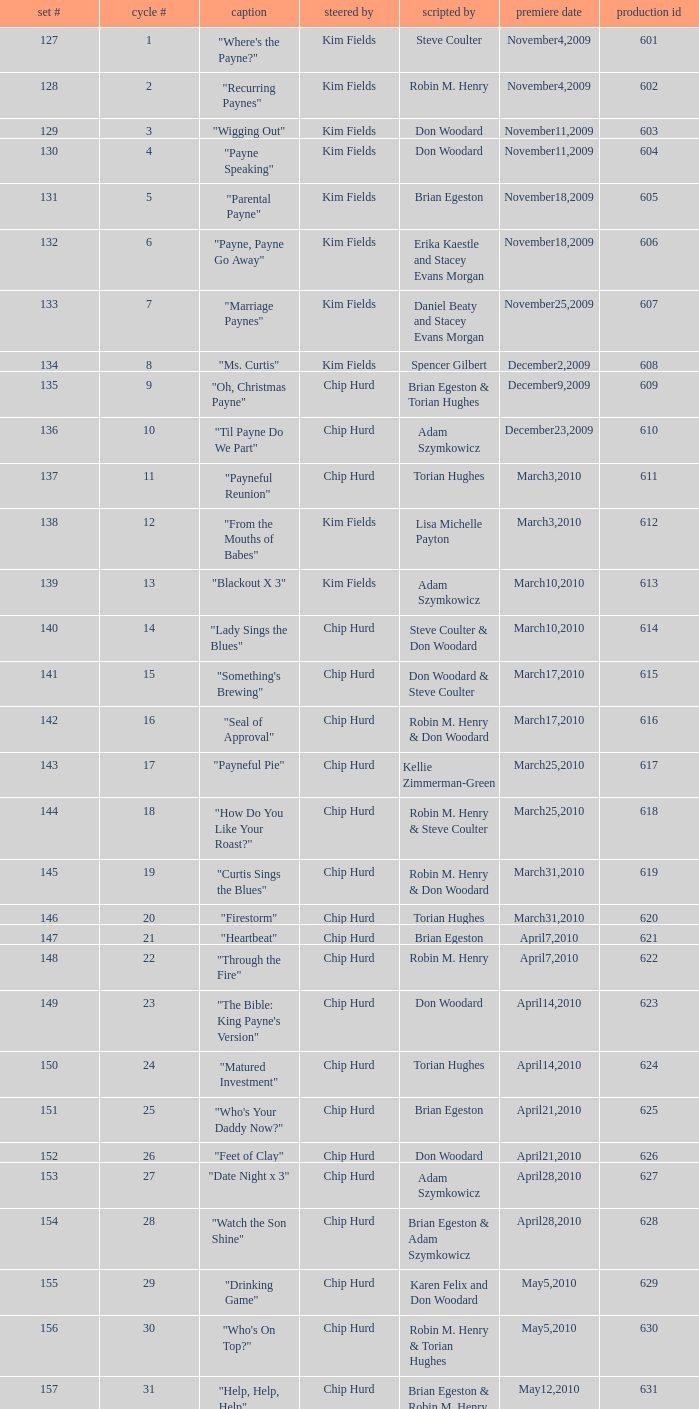What is the original air date of the episode written by Karen Felix and Don Woodard? May5,2010. Write the full table. {'header': ['set #', 'cycle #', 'caption', 'steered by', 'scripted by', 'premiere date', 'production id'], 'rows': [['127', '1', '"Where\'s the Payne?"', 'Kim Fields', 'Steve Coulter', 'November4,2009', '601'], ['128', '2', '"Recurring Paynes"', 'Kim Fields', 'Robin M. Henry', 'November4,2009', '602'], ['129', '3', '"Wigging Out"', 'Kim Fields', 'Don Woodard', 'November11,2009', '603'], ['130', '4', '"Payne Speaking"', 'Kim Fields', 'Don Woodard', 'November11,2009', '604'], ['131', '5', '"Parental Payne"', 'Kim Fields', 'Brian Egeston', 'November18,2009', '605'], ['132', '6', '"Payne, Payne Go Away"', 'Kim Fields', 'Erika Kaestle and Stacey Evans Morgan', 'November18,2009', '606'], ['133', '7', '"Marriage Paynes"', 'Kim Fields', 'Daniel Beaty and Stacey Evans Morgan', 'November25,2009', '607'], ['134', '8', '"Ms. Curtis"', 'Kim Fields', 'Spencer Gilbert', 'December2,2009', '608'], ['135', '9', '"Oh, Christmas Payne"', 'Chip Hurd', 'Brian Egeston & Torian Hughes', 'December9,2009', '609'], ['136', '10', '"Til Payne Do We Part"', 'Chip Hurd', 'Adam Szymkowicz', 'December23,2009', '610'], ['137', '11', '"Payneful Reunion"', 'Chip Hurd', 'Torian Hughes', 'March3,2010', '611'], ['138', '12', '"From the Mouths of Babes"', 'Kim Fields', 'Lisa Michelle Payton', 'March3,2010', '612'], ['139', '13', '"Blackout X 3"', 'Kim Fields', 'Adam Szymkowicz', 'March10,2010', '613'], ['140', '14', '"Lady Sings the Blues"', 'Chip Hurd', 'Steve Coulter & Don Woodard', 'March10,2010', '614'], ['141', '15', '"Something\'s Brewing"', 'Chip Hurd', 'Don Woodard & Steve Coulter', 'March17,2010', '615'], ['142', '16', '"Seal of Approval"', 'Chip Hurd', 'Robin M. Henry & Don Woodard', 'March17,2010', '616'], ['143', '17', '"Payneful Pie"', 'Chip Hurd', 'Kellie Zimmerman-Green', 'March25,2010', '617'], ['144', '18', '"How Do You Like Your Roast?"', 'Chip Hurd', 'Robin M. Henry & Steve Coulter', 'March25,2010', '618'], ['145', '19', '"Curtis Sings the Blues"', 'Chip Hurd', 'Robin M. Henry & Don Woodard', 'March31,2010', '619'], ['146', '20', '"Firestorm"', 'Chip Hurd', 'Torian Hughes', 'March31,2010', '620'], ['147', '21', '"Heartbeat"', 'Chip Hurd', 'Brian Egeston', 'April7,2010', '621'], ['148', '22', '"Through the Fire"', 'Chip Hurd', 'Robin M. Henry', 'April7,2010', '622'], ['149', '23', '"The Bible: King Payne\'s Version"', 'Chip Hurd', 'Don Woodard', 'April14,2010', '623'], ['150', '24', '"Matured Investment"', 'Chip Hurd', 'Torian Hughes', 'April14,2010', '624'], ['151', '25', '"Who\'s Your Daddy Now?"', 'Chip Hurd', 'Brian Egeston', 'April21,2010', '625'], ['152', '26', '"Feet of Clay"', 'Chip Hurd', 'Don Woodard', 'April21,2010', '626'], ['153', '27', '"Date Night x 3"', 'Chip Hurd', 'Adam Szymkowicz', 'April28,2010', '627'], ['154', '28', '"Watch the Son Shine"', 'Chip Hurd', 'Brian Egeston & Adam Szymkowicz', 'April28,2010', '628'], ['155', '29', '"Drinking Game"', 'Chip Hurd', 'Karen Felix and Don Woodard', 'May5,2010', '629'], ['156', '30', '"Who\'s On Top?"', 'Chip Hurd', 'Robin M. Henry & Torian Hughes', 'May5,2010', '630'], ['157', '31', '"Help, Help, Help"', 'Chip Hurd', 'Brian Egeston & Robin M. Henry', 'May12,2010', '631'], ['158', '32', '"Stinging Payne"', 'Chip Hurd', 'Don Woodard', 'May12,2010', '632'], ['159', '33', '"Worth Fighting For"', 'Chip Hurd', 'Torian Hughes', 'May19,2010', '633'], ['160', '34', '"Who\'s Your Nanny?"', 'Chip Hurd', 'Robin M. Henry & Adam Szymkowicz', 'May19,2010', '634'], ['161', '35', '"The Chef"', 'Chip Hurd', 'Anthony C. Hill', 'May26,2010', '635'], ['162', '36', '"My Fair Curtis"', 'Chip Hurd', 'Don Woodard', 'May26,2010', '636'], ['163', '37', '"Rest for the Weary"', 'Chip Hurd', 'Brian Egeston', 'June2,2010', '637'], ['164', '38', '"Thug Life"', 'Chip Hurd', 'Torian Hughes', 'June2,2010', '638'], ['165', '39', '"Rehabilitation"', 'Chip Hurd', 'Adam Szymkowicz', 'June9,2010', '639'], ['166', '40', '"A Payne In Need Is A Pain Indeed"', 'Chip Hurd', 'Don Woodard', 'June9,2010', '640'], ['167', '41', '"House Guest"', 'Chip Hurd', 'David A. Arnold', 'January5,2011', '641'], ['168', '42', '"Payne Showers"', 'Chip Hurd', 'Omega Mariaunnie Stewart and Torian Hughes', 'January5,2011', '642'], ['169', '43', '"Playing With Fire"', 'Chip Hurd', 'Carlos Portugal', 'January12,2011', '643'], ['170', '44', '"When the Payne\'s Away"', 'Chip Hurd', 'Kristin Topps and Don Woodard', 'January12,2011', '644'], ['171', '45', '"Beginnings"', 'Chip Hurd', 'Myra J.', 'January19,2011', '645']]} 